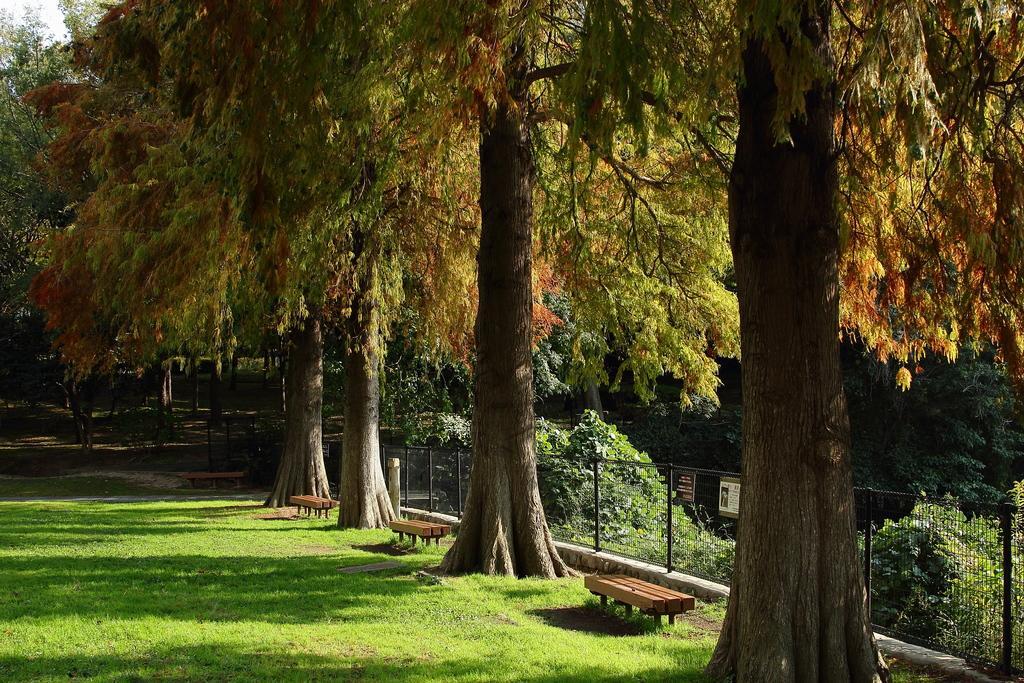Describe this image in one or two sentences. in this image there are trees, beneath the trees there are benches on the surface of the grass, behind them there is a railing with net. 